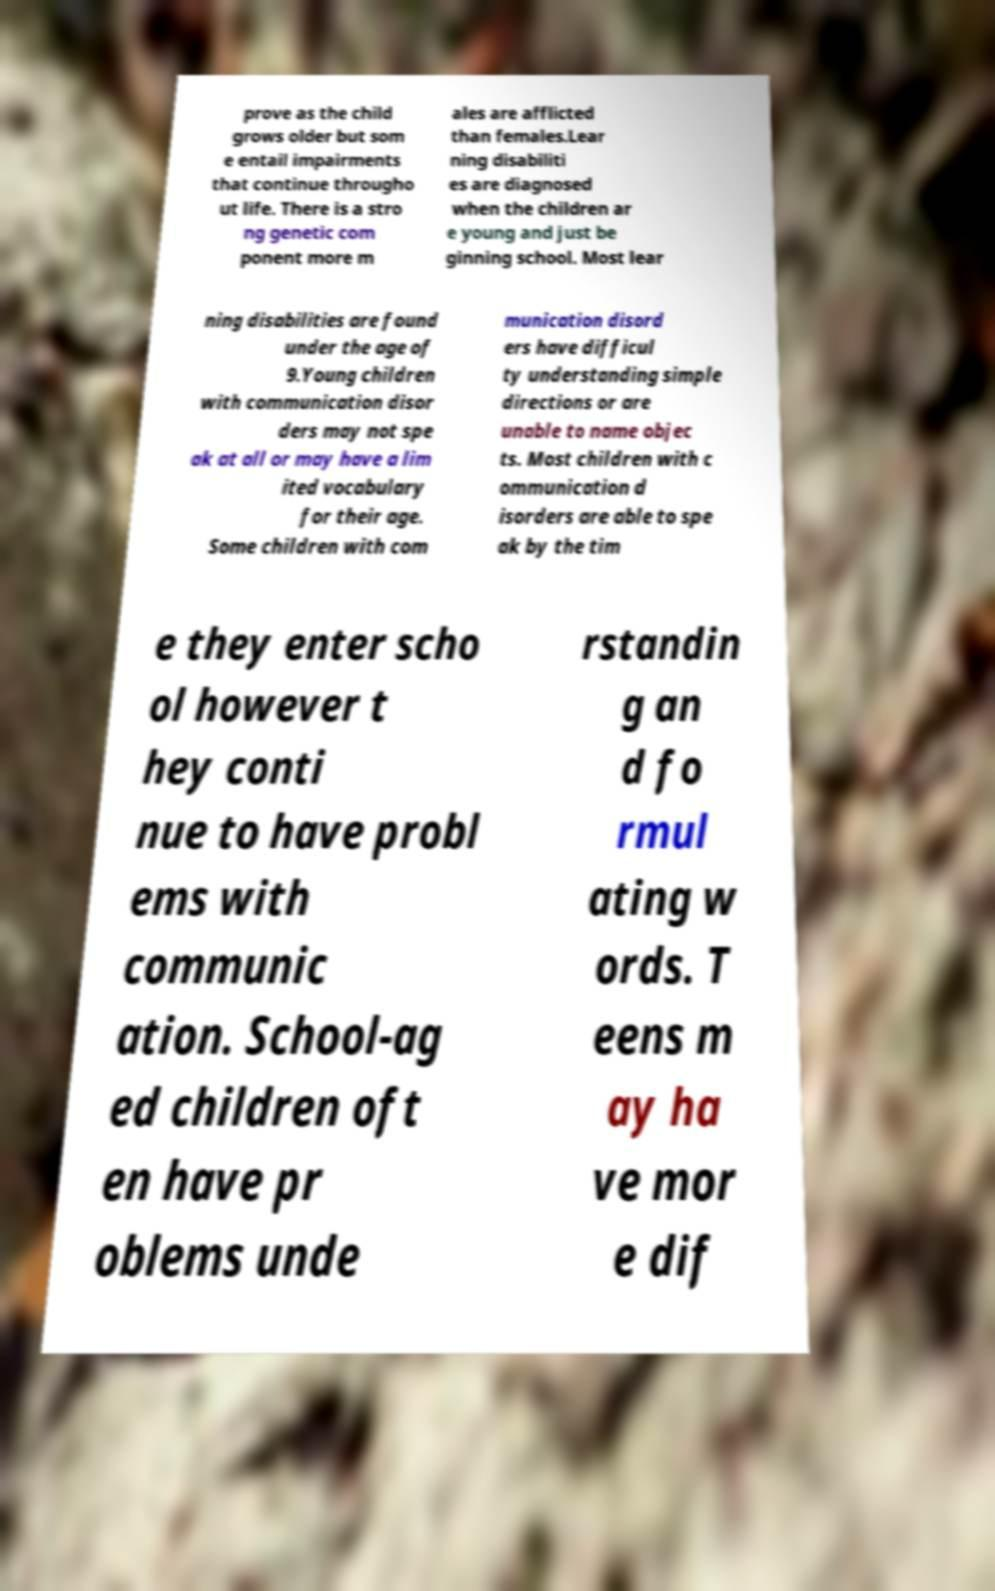There's text embedded in this image that I need extracted. Can you transcribe it verbatim? prove as the child grows older but som e entail impairments that continue througho ut life. There is a stro ng genetic com ponent more m ales are afflicted than females.Lear ning disabiliti es are diagnosed when the children ar e young and just be ginning school. Most lear ning disabilities are found under the age of 9.Young children with communication disor ders may not spe ak at all or may have a lim ited vocabulary for their age. Some children with com munication disord ers have difficul ty understanding simple directions or are unable to name objec ts. Most children with c ommunication d isorders are able to spe ak by the tim e they enter scho ol however t hey conti nue to have probl ems with communic ation. School-ag ed children oft en have pr oblems unde rstandin g an d fo rmul ating w ords. T eens m ay ha ve mor e dif 